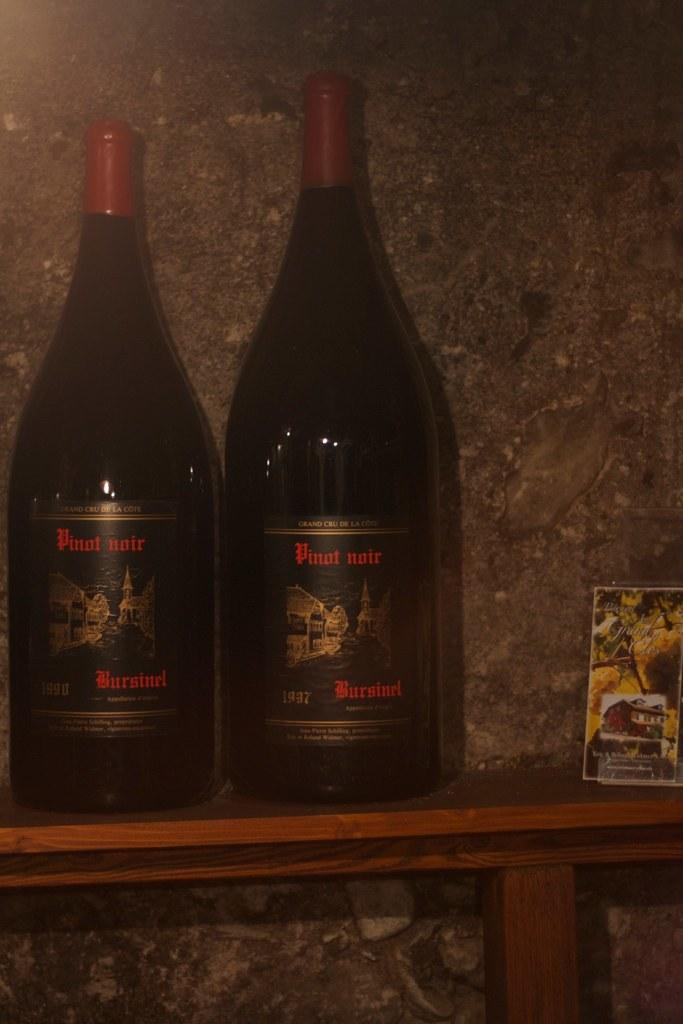<image>
Summarize the visual content of the image. Two dark bottles of Pinot Noir are on the shelf up against the gray wall. 